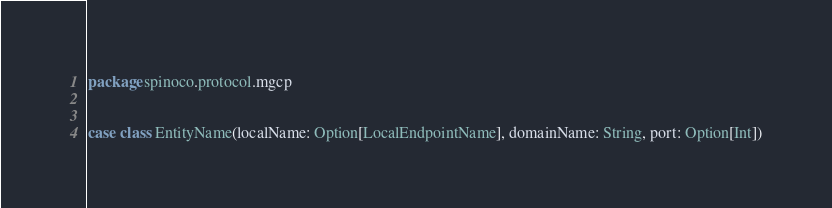<code> <loc_0><loc_0><loc_500><loc_500><_Scala_>package spinoco.protocol.mgcp


case class EntityName(localName: Option[LocalEndpointName], domainName: String, port: Option[Int])
</code> 